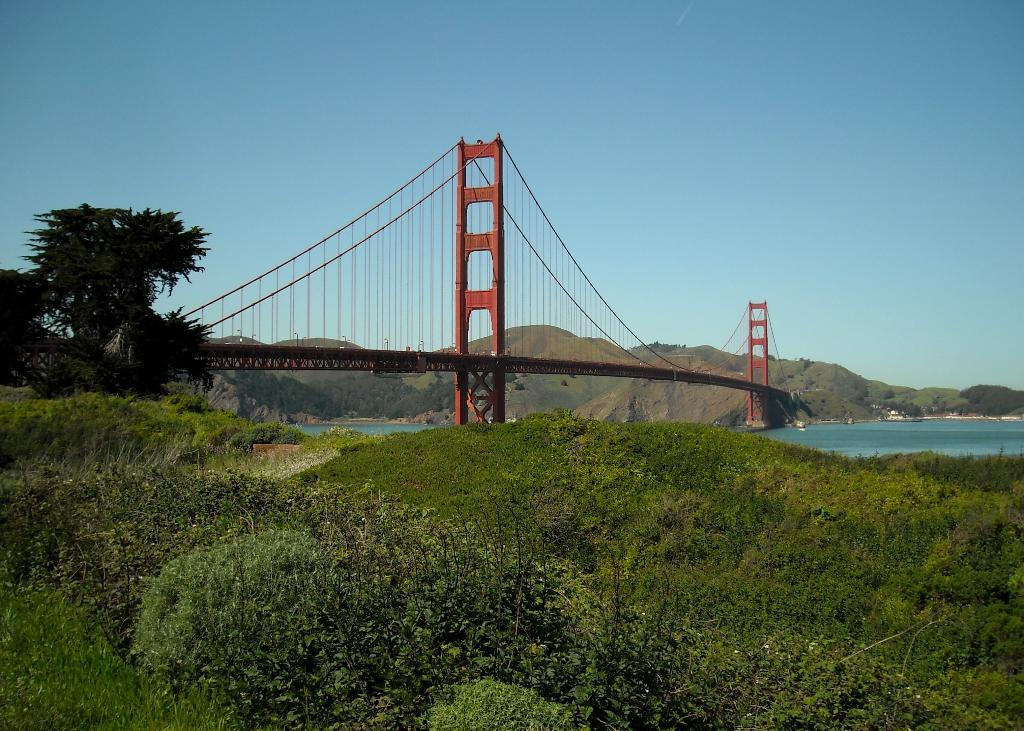What types of living organisms can be seen in the image? Plants and trees are visible in the image. What type of structure can be seen in the image? There is a bridge in the image. How is the bridge positioned in the image? The bridge connects two corners of a hill. What is visible in the background of the image? The sky is visible in the background of the image. What type of ray can be seen swimming in the image? There is no ray present in the image; it features plants, trees, a bridge, and a hill. 